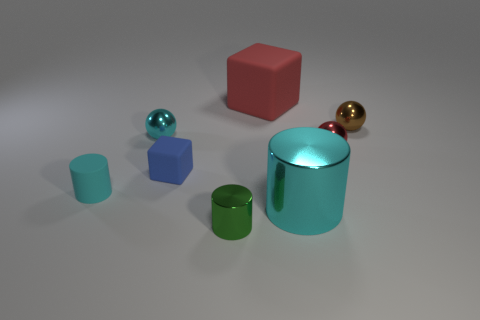What lighting conditions are present in the scene? The scene is lit with a soft, diffused light that casts gentle shadows beneath the objects, suggesting an even and indirect light source, possibly overhead. This lighting contributes to the calm and neutral atmosphere of the composition. 